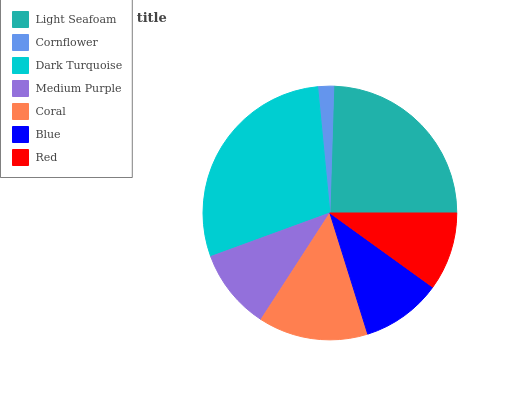Is Cornflower the minimum?
Answer yes or no. Yes. Is Dark Turquoise the maximum?
Answer yes or no. Yes. Is Dark Turquoise the minimum?
Answer yes or no. No. Is Cornflower the maximum?
Answer yes or no. No. Is Dark Turquoise greater than Cornflower?
Answer yes or no. Yes. Is Cornflower less than Dark Turquoise?
Answer yes or no. Yes. Is Cornflower greater than Dark Turquoise?
Answer yes or no. No. Is Dark Turquoise less than Cornflower?
Answer yes or no. No. Is Medium Purple the high median?
Answer yes or no. Yes. Is Medium Purple the low median?
Answer yes or no. Yes. Is Red the high median?
Answer yes or no. No. Is Red the low median?
Answer yes or no. No. 